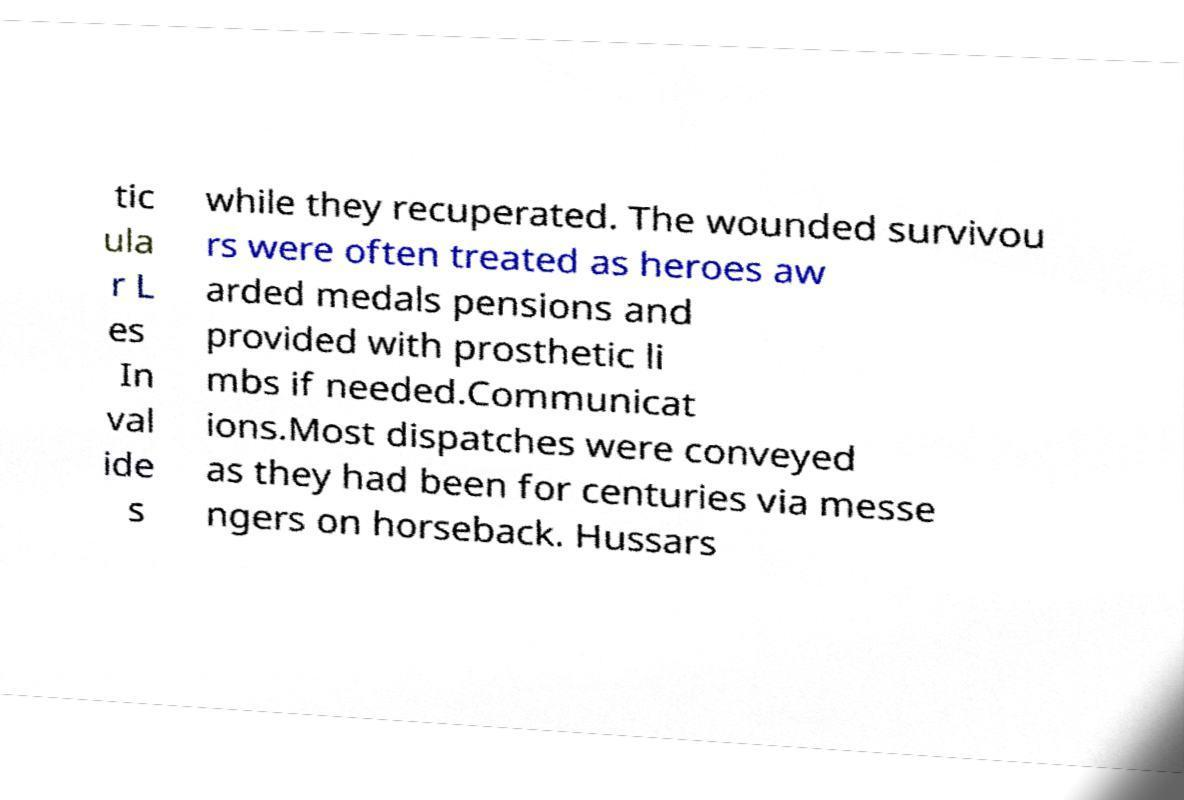Please read and relay the text visible in this image. What does it say? tic ula r L es In val ide s while they recuperated. The wounded survivou rs were often treated as heroes aw arded medals pensions and provided with prosthetic li mbs if needed.Communicat ions.Most dispatches were conveyed as they had been for centuries via messe ngers on horseback. Hussars 